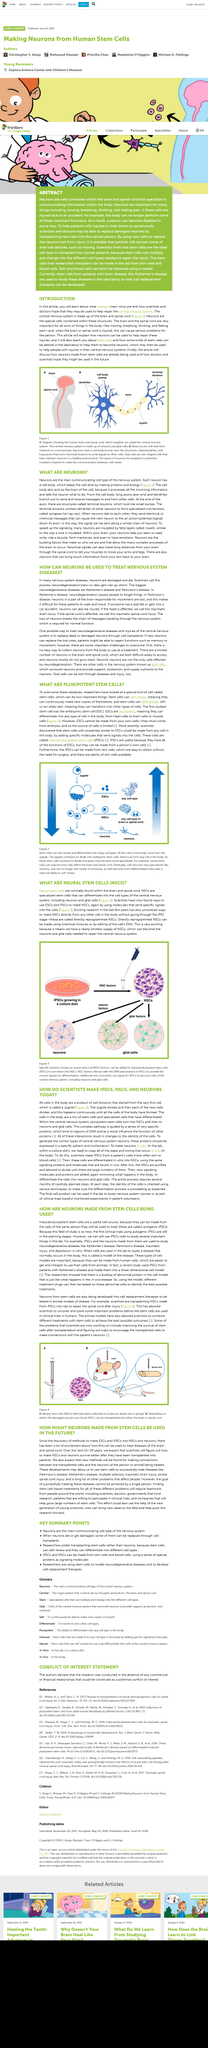Point out several critical features in this image. The brain and spinal cord are the fundamental components of the central nervous system. Scientists have successfully used embryonic stem cells (ESCs) and induced pluripotent stem cells (iPSCs) to generate neural stem cells (NSCs) by administering specific signaling molecules to the cells. A directly programmed NSC is a type of NSC that is created directly from cells in the body without the intermediate iPSC stage. The brain and spinal cord are crucial for various bodily functions, including movement, breathing, thought processes, and sensations such as pain. Neural stem cells are specialized stem cells that are found within the brain and spinal cord and have the ability to differentiate into neurons and glial cells of the central nervous system. 